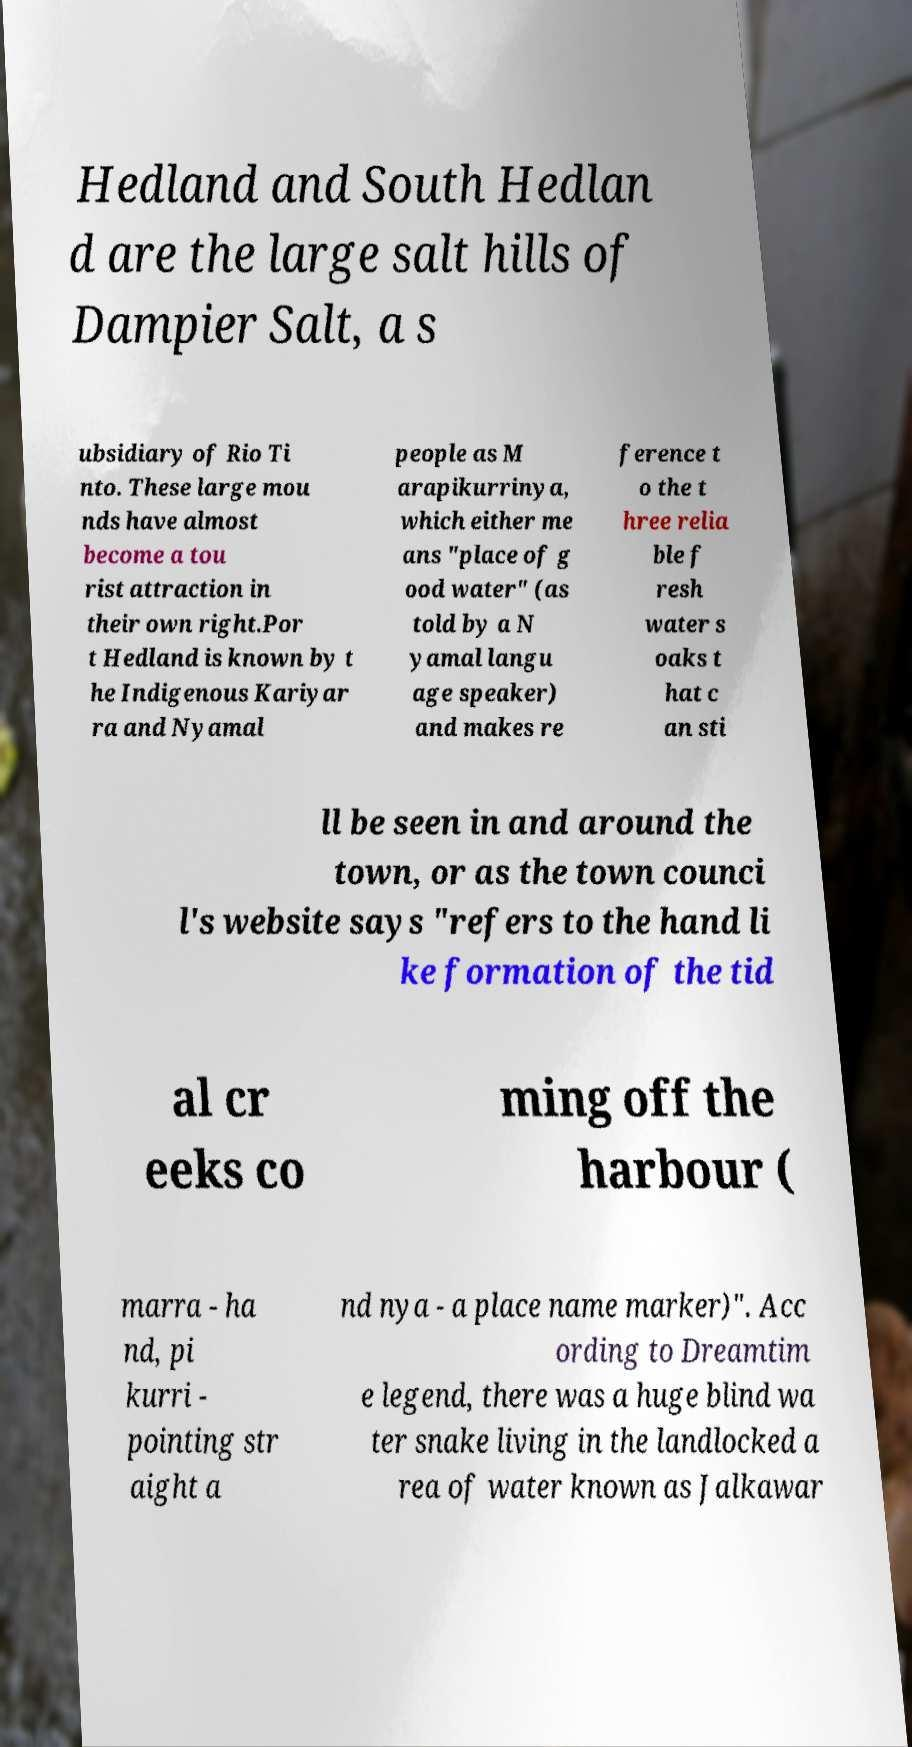Can you accurately transcribe the text from the provided image for me? Hedland and South Hedlan d are the large salt hills of Dampier Salt, a s ubsidiary of Rio Ti nto. These large mou nds have almost become a tou rist attraction in their own right.Por t Hedland is known by t he Indigenous Kariyar ra and Nyamal people as M arapikurrinya, which either me ans "place of g ood water" (as told by a N yamal langu age speaker) and makes re ference t o the t hree relia ble f resh water s oaks t hat c an sti ll be seen in and around the town, or as the town counci l's website says "refers to the hand li ke formation of the tid al cr eeks co ming off the harbour ( marra - ha nd, pi kurri - pointing str aight a nd nya - a place name marker)". Acc ording to Dreamtim e legend, there was a huge blind wa ter snake living in the landlocked a rea of water known as Jalkawar 